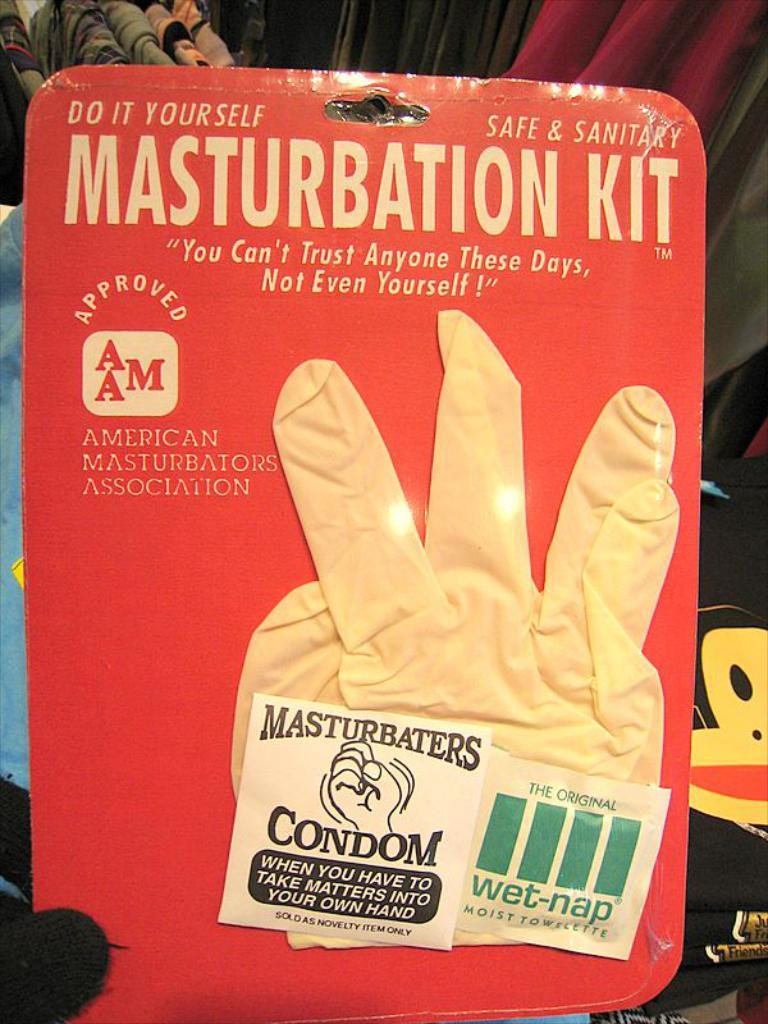Provide a one-sentence caption for the provided image. A comical product called the Masturbation Kit contains a rubber glove, a condom and a packet of wet wipes. 